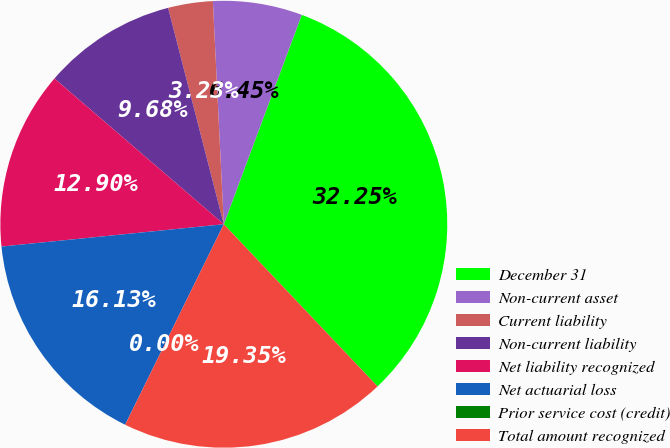<chart> <loc_0><loc_0><loc_500><loc_500><pie_chart><fcel>December 31<fcel>Non-current asset<fcel>Current liability<fcel>Non-current liability<fcel>Net liability recognized<fcel>Net actuarial loss<fcel>Prior service cost (credit)<fcel>Total amount recognized<nl><fcel>32.25%<fcel>6.45%<fcel>3.23%<fcel>9.68%<fcel>12.9%<fcel>16.13%<fcel>0.0%<fcel>19.35%<nl></chart> 